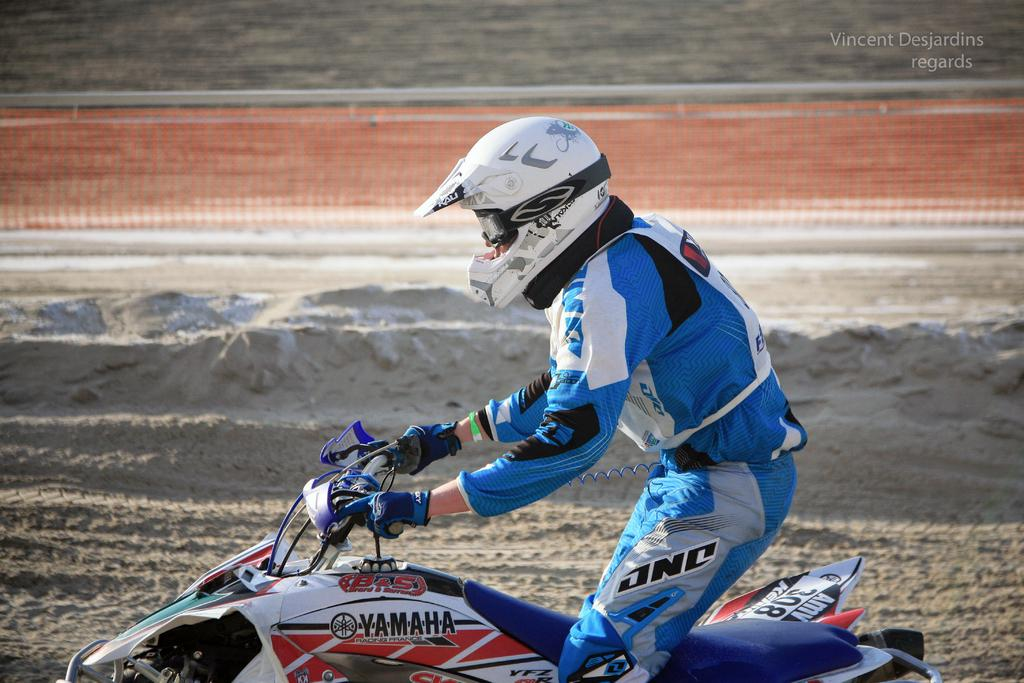What is present in the image? There is a person in the image. What is the person wearing on their head? The person is wearing a helmet. What mode of transportation is the person using? The person is on a vehicle. What type of terrain can be seen in the image? There is sand on the ground in the image. What type of tooth is visible in the image? There is no tooth present in the image. How many soldiers are visible in the image? There is no army or soldiers present in the image. 